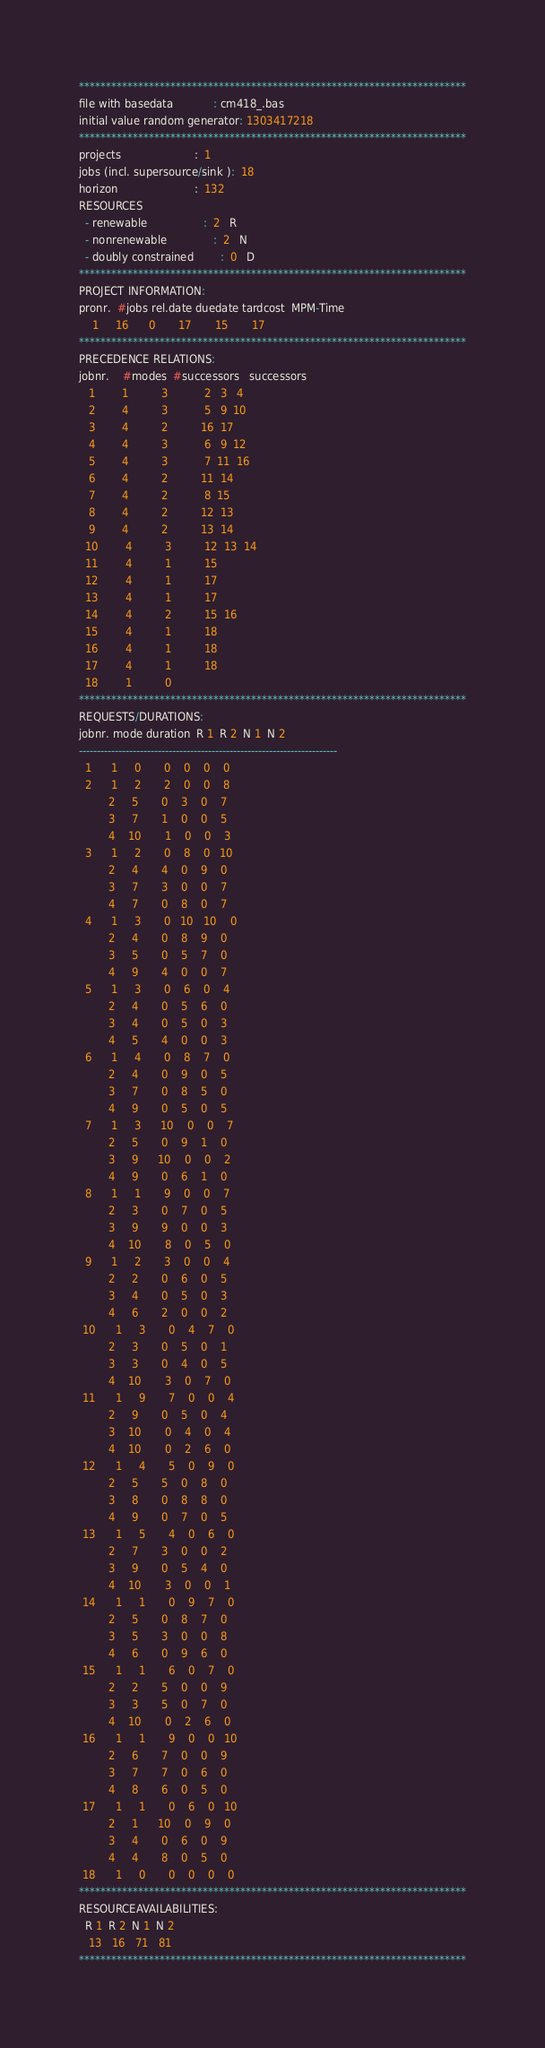<code> <loc_0><loc_0><loc_500><loc_500><_ObjectiveC_>************************************************************************
file with basedata            : cm418_.bas
initial value random generator: 1303417218
************************************************************************
projects                      :  1
jobs (incl. supersource/sink ):  18
horizon                       :  132
RESOURCES
  - renewable                 :  2   R
  - nonrenewable              :  2   N
  - doubly constrained        :  0   D
************************************************************************
PROJECT INFORMATION:
pronr.  #jobs rel.date duedate tardcost  MPM-Time
    1     16      0       17       15       17
************************************************************************
PRECEDENCE RELATIONS:
jobnr.    #modes  #successors   successors
   1        1          3           2   3   4
   2        4          3           5   9  10
   3        4          2          16  17
   4        4          3           6   9  12
   5        4          3           7  11  16
   6        4          2          11  14
   7        4          2           8  15
   8        4          2          12  13
   9        4          2          13  14
  10        4          3          12  13  14
  11        4          1          15
  12        4          1          17
  13        4          1          17
  14        4          2          15  16
  15        4          1          18
  16        4          1          18
  17        4          1          18
  18        1          0        
************************************************************************
REQUESTS/DURATIONS:
jobnr. mode duration  R 1  R 2  N 1  N 2
------------------------------------------------------------------------
  1      1     0       0    0    0    0
  2      1     2       2    0    0    8
         2     5       0    3    0    7
         3     7       1    0    0    5
         4    10       1    0    0    3
  3      1     2       0    8    0   10
         2     4       4    0    9    0
         3     7       3    0    0    7
         4     7       0    8    0    7
  4      1     3       0   10   10    0
         2     4       0    8    9    0
         3     5       0    5    7    0
         4     9       4    0    0    7
  5      1     3       0    6    0    4
         2     4       0    5    6    0
         3     4       0    5    0    3
         4     5       4    0    0    3
  6      1     4       0    8    7    0
         2     4       0    9    0    5
         3     7       0    8    5    0
         4     9       0    5    0    5
  7      1     3      10    0    0    7
         2     5       0    9    1    0
         3     9      10    0    0    2
         4     9       0    6    1    0
  8      1     1       9    0    0    7
         2     3       0    7    0    5
         3     9       9    0    0    3
         4    10       8    0    5    0
  9      1     2       3    0    0    4
         2     2       0    6    0    5
         3     4       0    5    0    3
         4     6       2    0    0    2
 10      1     3       0    4    7    0
         2     3       0    5    0    1
         3     3       0    4    0    5
         4    10       3    0    7    0
 11      1     9       7    0    0    4
         2     9       0    5    0    4
         3    10       0    4    0    4
         4    10       0    2    6    0
 12      1     4       5    0    9    0
         2     5       5    0    8    0
         3     8       0    8    8    0
         4     9       0    7    0    5
 13      1     5       4    0    6    0
         2     7       3    0    0    2
         3     9       0    5    4    0
         4    10       3    0    0    1
 14      1     1       0    9    7    0
         2     5       0    8    7    0
         3     5       3    0    0    8
         4     6       0    9    6    0
 15      1     1       6    0    7    0
         2     2       5    0    0    9
         3     3       5    0    7    0
         4    10       0    2    6    0
 16      1     1       9    0    0   10
         2     6       7    0    0    9
         3     7       7    0    6    0
         4     8       6    0    5    0
 17      1     1       0    6    0   10
         2     1      10    0    9    0
         3     4       0    6    0    9
         4     4       8    0    5    0
 18      1     0       0    0    0    0
************************************************************************
RESOURCEAVAILABILITIES:
  R 1  R 2  N 1  N 2
   13   16   71   81
************************************************************************
</code> 